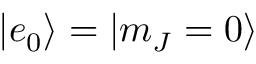Convert formula to latex. <formula><loc_0><loc_0><loc_500><loc_500>| e _ { 0 } \rangle = | m _ { J } = 0 \rangle</formula> 